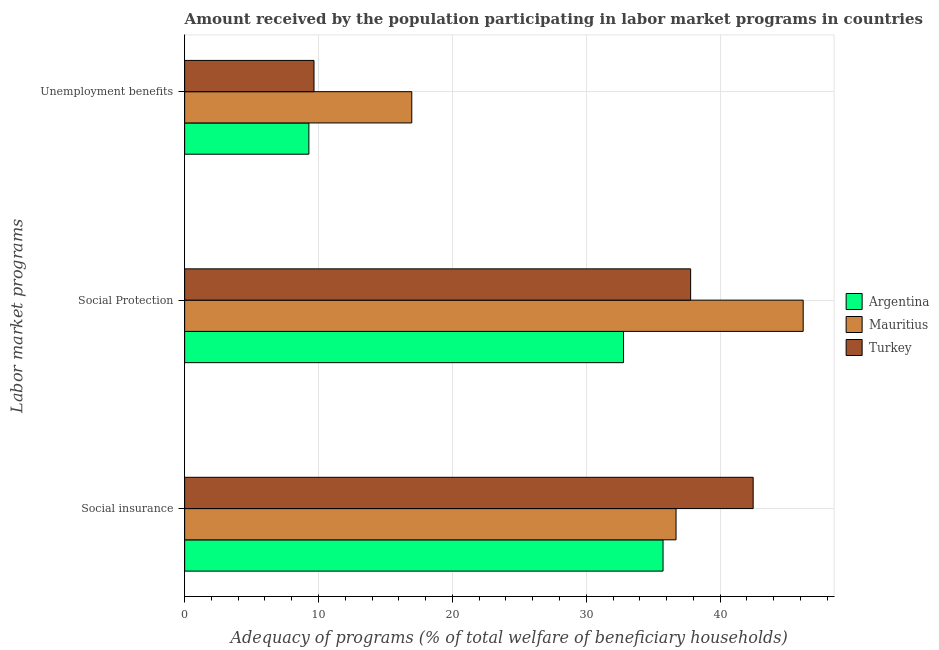Are the number of bars per tick equal to the number of legend labels?
Offer a very short reply. Yes. How many bars are there on the 1st tick from the top?
Your response must be concise. 3. What is the label of the 3rd group of bars from the top?
Provide a short and direct response. Social insurance. What is the amount received by the population participating in unemployment benefits programs in Argentina?
Ensure brevity in your answer.  9.28. Across all countries, what is the maximum amount received by the population participating in unemployment benefits programs?
Keep it short and to the point. 16.97. Across all countries, what is the minimum amount received by the population participating in social protection programs?
Provide a succinct answer. 32.79. In which country was the amount received by the population participating in social insurance programs maximum?
Offer a very short reply. Turkey. What is the total amount received by the population participating in social protection programs in the graph?
Give a very brief answer. 116.79. What is the difference between the amount received by the population participating in social insurance programs in Mauritius and that in Argentina?
Offer a terse response. 0.97. What is the difference between the amount received by the population participating in social insurance programs in Argentina and the amount received by the population participating in social protection programs in Mauritius?
Offer a terse response. -10.47. What is the average amount received by the population participating in unemployment benefits programs per country?
Offer a very short reply. 11.97. What is the difference between the amount received by the population participating in unemployment benefits programs and amount received by the population participating in social insurance programs in Mauritius?
Ensure brevity in your answer.  -19.74. What is the ratio of the amount received by the population participating in social insurance programs in Mauritius to that in Argentina?
Offer a very short reply. 1.03. Is the amount received by the population participating in unemployment benefits programs in Argentina less than that in Turkey?
Your answer should be compact. Yes. Is the difference between the amount received by the population participating in social insurance programs in Argentina and Turkey greater than the difference between the amount received by the population participating in unemployment benefits programs in Argentina and Turkey?
Offer a very short reply. No. What is the difference between the highest and the second highest amount received by the population participating in social protection programs?
Provide a short and direct response. 8.41. What is the difference between the highest and the lowest amount received by the population participating in unemployment benefits programs?
Ensure brevity in your answer.  7.69. What does the 3rd bar from the top in Social insurance represents?
Your answer should be very brief. Argentina. What does the 2nd bar from the bottom in Unemployment benefits represents?
Give a very brief answer. Mauritius. Is it the case that in every country, the sum of the amount received by the population participating in social insurance programs and amount received by the population participating in social protection programs is greater than the amount received by the population participating in unemployment benefits programs?
Your answer should be compact. Yes. Are all the bars in the graph horizontal?
Your answer should be very brief. Yes. What is the difference between two consecutive major ticks on the X-axis?
Give a very brief answer. 10. Are the values on the major ticks of X-axis written in scientific E-notation?
Your response must be concise. No. Does the graph contain any zero values?
Your answer should be very brief. No. How many legend labels are there?
Keep it short and to the point. 3. How are the legend labels stacked?
Ensure brevity in your answer.  Vertical. What is the title of the graph?
Provide a short and direct response. Amount received by the population participating in labor market programs in countries. What is the label or title of the X-axis?
Provide a short and direct response. Adequacy of programs (% of total welfare of beneficiary households). What is the label or title of the Y-axis?
Your response must be concise. Labor market programs. What is the Adequacy of programs (% of total welfare of beneficiary households) of Argentina in Social insurance?
Provide a short and direct response. 35.74. What is the Adequacy of programs (% of total welfare of beneficiary households) of Mauritius in Social insurance?
Keep it short and to the point. 36.71. What is the Adequacy of programs (% of total welfare of beneficiary households) of Turkey in Social insurance?
Give a very brief answer. 42.47. What is the Adequacy of programs (% of total welfare of beneficiary households) in Argentina in Social Protection?
Keep it short and to the point. 32.79. What is the Adequacy of programs (% of total welfare of beneficiary households) of Mauritius in Social Protection?
Your answer should be very brief. 46.21. What is the Adequacy of programs (% of total welfare of beneficiary households) of Turkey in Social Protection?
Offer a very short reply. 37.8. What is the Adequacy of programs (% of total welfare of beneficiary households) of Argentina in Unemployment benefits?
Offer a terse response. 9.28. What is the Adequacy of programs (% of total welfare of beneficiary households) of Mauritius in Unemployment benefits?
Keep it short and to the point. 16.97. What is the Adequacy of programs (% of total welfare of beneficiary households) of Turkey in Unemployment benefits?
Provide a succinct answer. 9.66. Across all Labor market programs, what is the maximum Adequacy of programs (% of total welfare of beneficiary households) of Argentina?
Keep it short and to the point. 35.74. Across all Labor market programs, what is the maximum Adequacy of programs (% of total welfare of beneficiary households) in Mauritius?
Make the answer very short. 46.21. Across all Labor market programs, what is the maximum Adequacy of programs (% of total welfare of beneficiary households) of Turkey?
Your response must be concise. 42.47. Across all Labor market programs, what is the minimum Adequacy of programs (% of total welfare of beneficiary households) of Argentina?
Offer a very short reply. 9.28. Across all Labor market programs, what is the minimum Adequacy of programs (% of total welfare of beneficiary households) of Mauritius?
Your response must be concise. 16.97. Across all Labor market programs, what is the minimum Adequacy of programs (% of total welfare of beneficiary households) in Turkey?
Give a very brief answer. 9.66. What is the total Adequacy of programs (% of total welfare of beneficiary households) of Argentina in the graph?
Your answer should be compact. 77.81. What is the total Adequacy of programs (% of total welfare of beneficiary households) in Mauritius in the graph?
Provide a succinct answer. 99.89. What is the total Adequacy of programs (% of total welfare of beneficiary households) in Turkey in the graph?
Ensure brevity in your answer.  89.93. What is the difference between the Adequacy of programs (% of total welfare of beneficiary households) in Argentina in Social insurance and that in Social Protection?
Your answer should be very brief. 2.95. What is the difference between the Adequacy of programs (% of total welfare of beneficiary households) in Mauritius in Social insurance and that in Social Protection?
Give a very brief answer. -9.5. What is the difference between the Adequacy of programs (% of total welfare of beneficiary households) in Turkey in Social insurance and that in Social Protection?
Keep it short and to the point. 4.67. What is the difference between the Adequacy of programs (% of total welfare of beneficiary households) of Argentina in Social insurance and that in Unemployment benefits?
Provide a succinct answer. 26.46. What is the difference between the Adequacy of programs (% of total welfare of beneficiary households) in Mauritius in Social insurance and that in Unemployment benefits?
Offer a terse response. 19.74. What is the difference between the Adequacy of programs (% of total welfare of beneficiary households) in Turkey in Social insurance and that in Unemployment benefits?
Provide a succinct answer. 32.81. What is the difference between the Adequacy of programs (% of total welfare of beneficiary households) of Argentina in Social Protection and that in Unemployment benefits?
Your answer should be compact. 23.5. What is the difference between the Adequacy of programs (% of total welfare of beneficiary households) of Mauritius in Social Protection and that in Unemployment benefits?
Make the answer very short. 29.24. What is the difference between the Adequacy of programs (% of total welfare of beneficiary households) of Turkey in Social Protection and that in Unemployment benefits?
Your answer should be compact. 28.14. What is the difference between the Adequacy of programs (% of total welfare of beneficiary households) of Argentina in Social insurance and the Adequacy of programs (% of total welfare of beneficiary households) of Mauritius in Social Protection?
Provide a succinct answer. -10.47. What is the difference between the Adequacy of programs (% of total welfare of beneficiary households) in Argentina in Social insurance and the Adequacy of programs (% of total welfare of beneficiary households) in Turkey in Social Protection?
Your response must be concise. -2.06. What is the difference between the Adequacy of programs (% of total welfare of beneficiary households) of Mauritius in Social insurance and the Adequacy of programs (% of total welfare of beneficiary households) of Turkey in Social Protection?
Ensure brevity in your answer.  -1.09. What is the difference between the Adequacy of programs (% of total welfare of beneficiary households) in Argentina in Social insurance and the Adequacy of programs (% of total welfare of beneficiary households) in Mauritius in Unemployment benefits?
Your answer should be very brief. 18.77. What is the difference between the Adequacy of programs (% of total welfare of beneficiary households) in Argentina in Social insurance and the Adequacy of programs (% of total welfare of beneficiary households) in Turkey in Unemployment benefits?
Provide a short and direct response. 26.08. What is the difference between the Adequacy of programs (% of total welfare of beneficiary households) in Mauritius in Social insurance and the Adequacy of programs (% of total welfare of beneficiary households) in Turkey in Unemployment benefits?
Provide a succinct answer. 27.05. What is the difference between the Adequacy of programs (% of total welfare of beneficiary households) in Argentina in Social Protection and the Adequacy of programs (% of total welfare of beneficiary households) in Mauritius in Unemployment benefits?
Your answer should be compact. 15.82. What is the difference between the Adequacy of programs (% of total welfare of beneficiary households) in Argentina in Social Protection and the Adequacy of programs (% of total welfare of beneficiary households) in Turkey in Unemployment benefits?
Your answer should be very brief. 23.12. What is the difference between the Adequacy of programs (% of total welfare of beneficiary households) in Mauritius in Social Protection and the Adequacy of programs (% of total welfare of beneficiary households) in Turkey in Unemployment benefits?
Make the answer very short. 36.54. What is the average Adequacy of programs (% of total welfare of beneficiary households) of Argentina per Labor market programs?
Your answer should be very brief. 25.94. What is the average Adequacy of programs (% of total welfare of beneficiary households) of Mauritius per Labor market programs?
Ensure brevity in your answer.  33.3. What is the average Adequacy of programs (% of total welfare of beneficiary households) of Turkey per Labor market programs?
Provide a succinct answer. 29.98. What is the difference between the Adequacy of programs (% of total welfare of beneficiary households) in Argentina and Adequacy of programs (% of total welfare of beneficiary households) in Mauritius in Social insurance?
Make the answer very short. -0.97. What is the difference between the Adequacy of programs (% of total welfare of beneficiary households) in Argentina and Adequacy of programs (% of total welfare of beneficiary households) in Turkey in Social insurance?
Keep it short and to the point. -6.73. What is the difference between the Adequacy of programs (% of total welfare of beneficiary households) in Mauritius and Adequacy of programs (% of total welfare of beneficiary households) in Turkey in Social insurance?
Ensure brevity in your answer.  -5.76. What is the difference between the Adequacy of programs (% of total welfare of beneficiary households) in Argentina and Adequacy of programs (% of total welfare of beneficiary households) in Mauritius in Social Protection?
Your response must be concise. -13.42. What is the difference between the Adequacy of programs (% of total welfare of beneficiary households) of Argentina and Adequacy of programs (% of total welfare of beneficiary households) of Turkey in Social Protection?
Your answer should be very brief. -5.01. What is the difference between the Adequacy of programs (% of total welfare of beneficiary households) in Mauritius and Adequacy of programs (% of total welfare of beneficiary households) in Turkey in Social Protection?
Your answer should be very brief. 8.41. What is the difference between the Adequacy of programs (% of total welfare of beneficiary households) in Argentina and Adequacy of programs (% of total welfare of beneficiary households) in Mauritius in Unemployment benefits?
Your response must be concise. -7.69. What is the difference between the Adequacy of programs (% of total welfare of beneficiary households) in Argentina and Adequacy of programs (% of total welfare of beneficiary households) in Turkey in Unemployment benefits?
Offer a very short reply. -0.38. What is the difference between the Adequacy of programs (% of total welfare of beneficiary households) of Mauritius and Adequacy of programs (% of total welfare of beneficiary households) of Turkey in Unemployment benefits?
Give a very brief answer. 7.3. What is the ratio of the Adequacy of programs (% of total welfare of beneficiary households) of Argentina in Social insurance to that in Social Protection?
Give a very brief answer. 1.09. What is the ratio of the Adequacy of programs (% of total welfare of beneficiary households) in Mauritius in Social insurance to that in Social Protection?
Your answer should be very brief. 0.79. What is the ratio of the Adequacy of programs (% of total welfare of beneficiary households) of Turkey in Social insurance to that in Social Protection?
Offer a very short reply. 1.12. What is the ratio of the Adequacy of programs (% of total welfare of beneficiary households) of Argentina in Social insurance to that in Unemployment benefits?
Give a very brief answer. 3.85. What is the ratio of the Adequacy of programs (% of total welfare of beneficiary households) of Mauritius in Social insurance to that in Unemployment benefits?
Offer a terse response. 2.16. What is the ratio of the Adequacy of programs (% of total welfare of beneficiary households) in Turkey in Social insurance to that in Unemployment benefits?
Provide a succinct answer. 4.39. What is the ratio of the Adequacy of programs (% of total welfare of beneficiary households) in Argentina in Social Protection to that in Unemployment benefits?
Your response must be concise. 3.53. What is the ratio of the Adequacy of programs (% of total welfare of beneficiary households) of Mauritius in Social Protection to that in Unemployment benefits?
Ensure brevity in your answer.  2.72. What is the ratio of the Adequacy of programs (% of total welfare of beneficiary households) in Turkey in Social Protection to that in Unemployment benefits?
Keep it short and to the point. 3.91. What is the difference between the highest and the second highest Adequacy of programs (% of total welfare of beneficiary households) of Argentina?
Offer a very short reply. 2.95. What is the difference between the highest and the second highest Adequacy of programs (% of total welfare of beneficiary households) of Mauritius?
Provide a succinct answer. 9.5. What is the difference between the highest and the second highest Adequacy of programs (% of total welfare of beneficiary households) in Turkey?
Make the answer very short. 4.67. What is the difference between the highest and the lowest Adequacy of programs (% of total welfare of beneficiary households) in Argentina?
Keep it short and to the point. 26.46. What is the difference between the highest and the lowest Adequacy of programs (% of total welfare of beneficiary households) in Mauritius?
Ensure brevity in your answer.  29.24. What is the difference between the highest and the lowest Adequacy of programs (% of total welfare of beneficiary households) in Turkey?
Offer a very short reply. 32.81. 